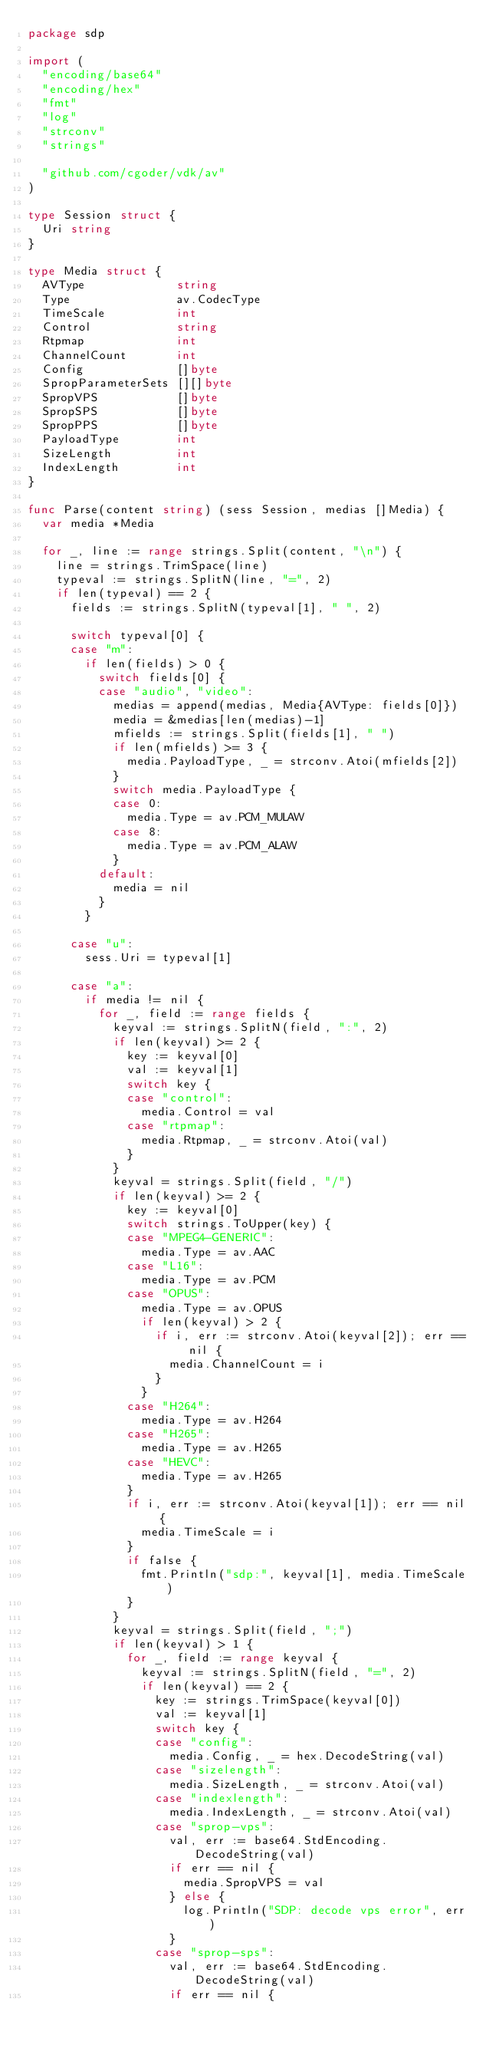Convert code to text. <code><loc_0><loc_0><loc_500><loc_500><_Go_>package sdp

import (
	"encoding/base64"
	"encoding/hex"
	"fmt"
	"log"
	"strconv"
	"strings"

	"github.com/cgoder/vdk/av"
)

type Session struct {
	Uri string
}

type Media struct {
	AVType             string
	Type               av.CodecType
	TimeScale          int
	Control            string
	Rtpmap             int
	ChannelCount       int
	Config             []byte
	SpropParameterSets [][]byte
	SpropVPS           []byte
	SpropSPS           []byte
	SpropPPS           []byte
	PayloadType        int
	SizeLength         int
	IndexLength        int
}

func Parse(content string) (sess Session, medias []Media) {
	var media *Media

	for _, line := range strings.Split(content, "\n") {
		line = strings.TrimSpace(line)
		typeval := strings.SplitN(line, "=", 2)
		if len(typeval) == 2 {
			fields := strings.SplitN(typeval[1], " ", 2)

			switch typeval[0] {
			case "m":
				if len(fields) > 0 {
					switch fields[0] {
					case "audio", "video":
						medias = append(medias, Media{AVType: fields[0]})
						media = &medias[len(medias)-1]
						mfields := strings.Split(fields[1], " ")
						if len(mfields) >= 3 {
							media.PayloadType, _ = strconv.Atoi(mfields[2])
						}
						switch media.PayloadType {
						case 0:
							media.Type = av.PCM_MULAW
						case 8:
							media.Type = av.PCM_ALAW
						}
					default:
						media = nil
					}
				}

			case "u":
				sess.Uri = typeval[1]

			case "a":
				if media != nil {
					for _, field := range fields {
						keyval := strings.SplitN(field, ":", 2)
						if len(keyval) >= 2 {
							key := keyval[0]
							val := keyval[1]
							switch key {
							case "control":
								media.Control = val
							case "rtpmap":
								media.Rtpmap, _ = strconv.Atoi(val)
							}
						}
						keyval = strings.Split(field, "/")
						if len(keyval) >= 2 {
							key := keyval[0]
							switch strings.ToUpper(key) {
							case "MPEG4-GENERIC":
								media.Type = av.AAC
							case "L16":
								media.Type = av.PCM
							case "OPUS":
								media.Type = av.OPUS
								if len(keyval) > 2 {
									if i, err := strconv.Atoi(keyval[2]); err == nil {
										media.ChannelCount = i
									}
								}
							case "H264":
								media.Type = av.H264
							case "H265":
								media.Type = av.H265
							case "HEVC":
								media.Type = av.H265
							}
							if i, err := strconv.Atoi(keyval[1]); err == nil {
								media.TimeScale = i
							}
							if false {
								fmt.Println("sdp:", keyval[1], media.TimeScale)
							}
						}
						keyval = strings.Split(field, ";")
						if len(keyval) > 1 {
							for _, field := range keyval {
								keyval := strings.SplitN(field, "=", 2)
								if len(keyval) == 2 {
									key := strings.TrimSpace(keyval[0])
									val := keyval[1]
									switch key {
									case "config":
										media.Config, _ = hex.DecodeString(val)
									case "sizelength":
										media.SizeLength, _ = strconv.Atoi(val)
									case "indexlength":
										media.IndexLength, _ = strconv.Atoi(val)
									case "sprop-vps":
										val, err := base64.StdEncoding.DecodeString(val)
										if err == nil {
											media.SpropVPS = val
										} else {
											log.Println("SDP: decode vps error", err)
										}
									case "sprop-sps":
										val, err := base64.StdEncoding.DecodeString(val)
										if err == nil {</code> 